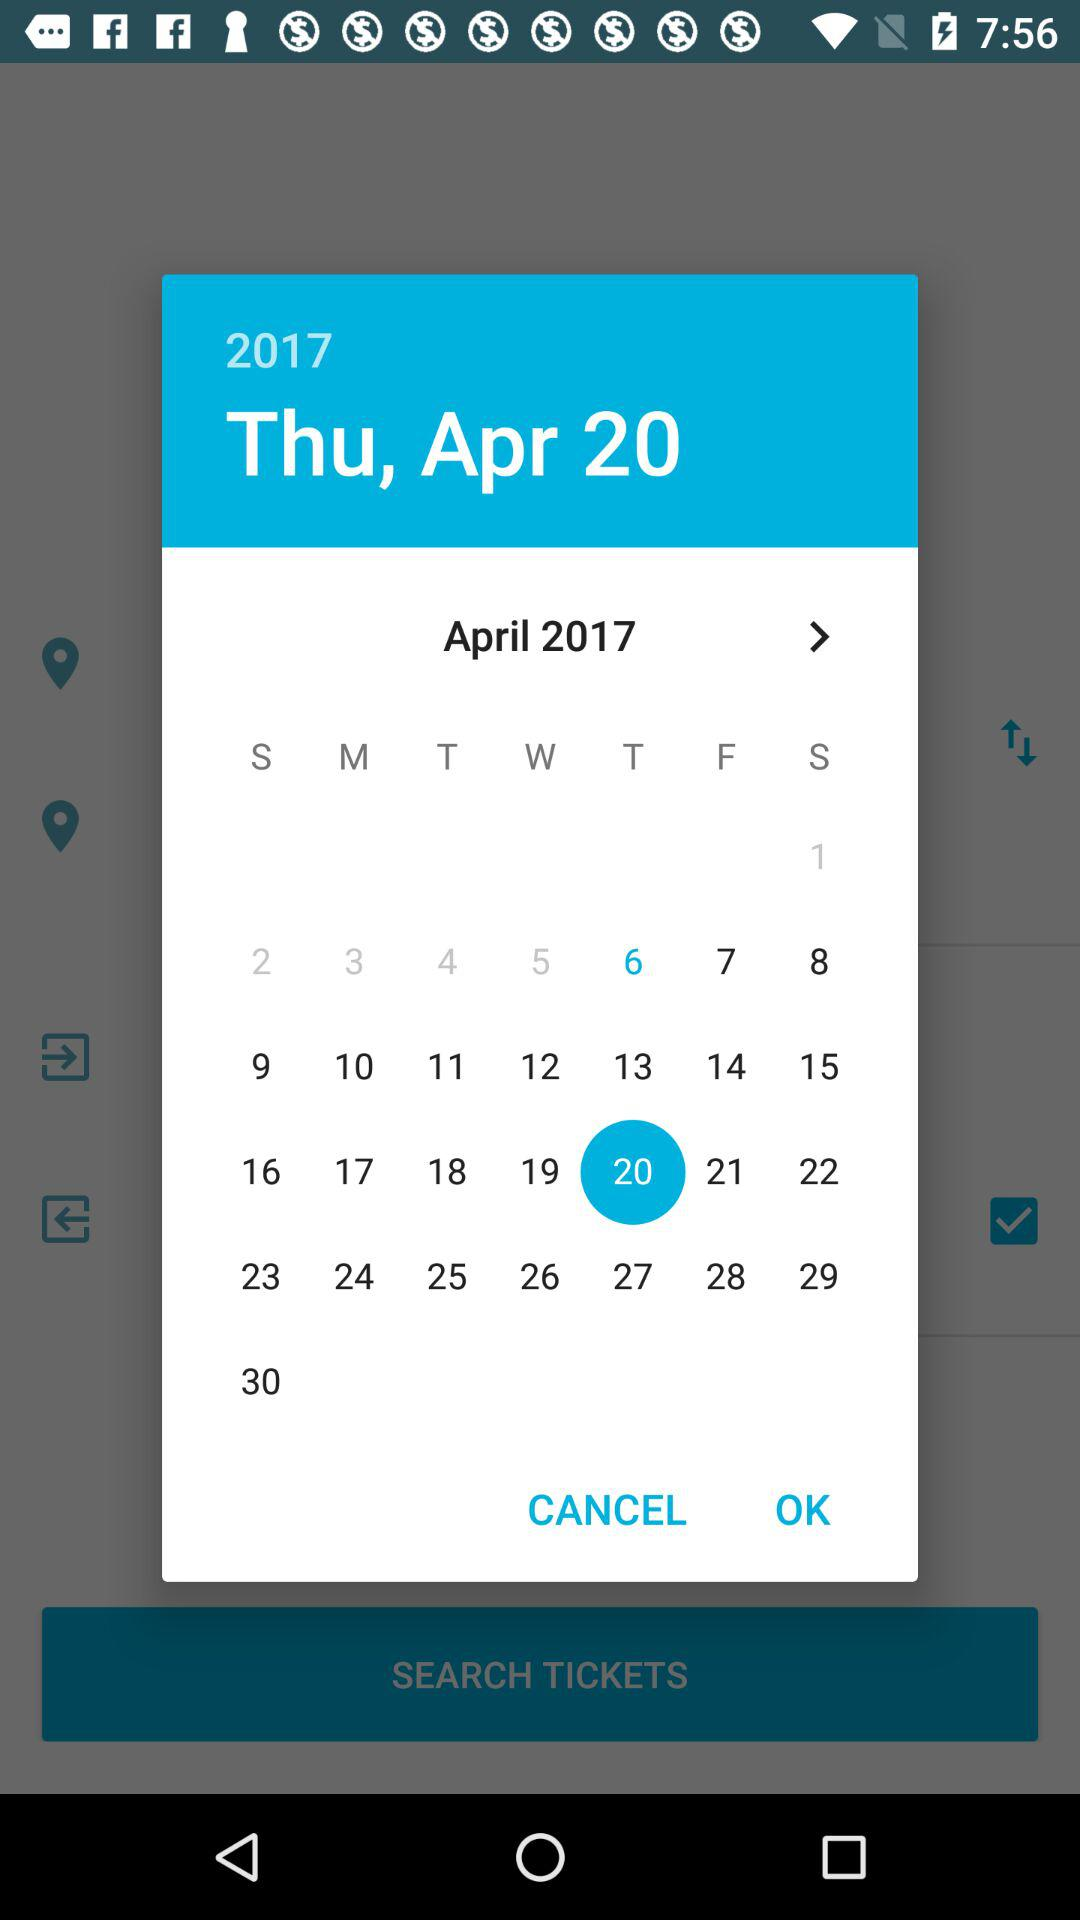What is the selected date? The selected date is Thursday, 20 April 2017. 